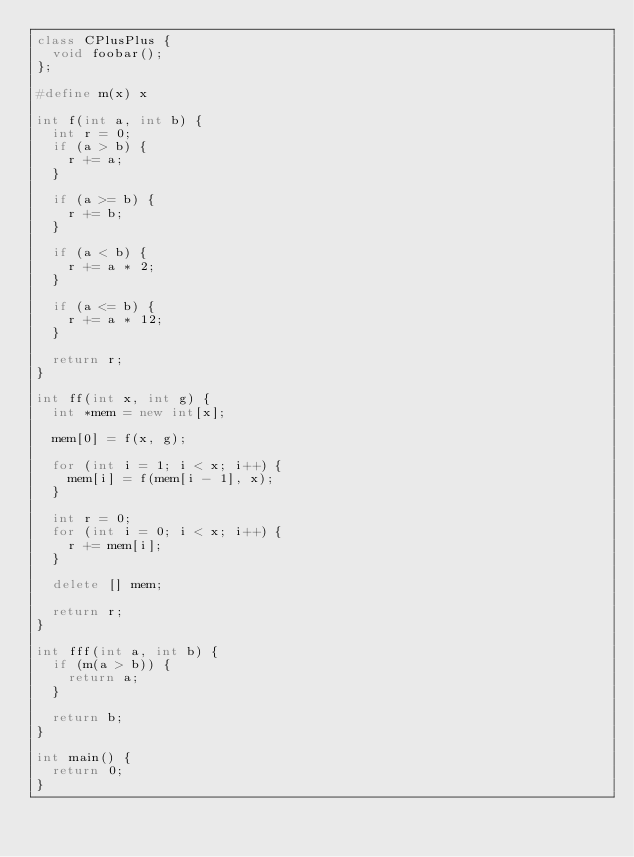Convert code to text. <code><loc_0><loc_0><loc_500><loc_500><_C++_>class CPlusPlus {
  void foobar();
};

#define m(x) x

int f(int a, int b) {
  int r = 0;
  if (a > b) {
    r += a;
  }

  if (a >= b) {
    r += b;
  }

  if (a < b) {
    r += a * 2;
  }

  if (a <= b) {
    r += a * 12;
  }

  return r;
}

int ff(int x, int g) {
  int *mem = new int[x];

  mem[0] = f(x, g);

  for (int i = 1; i < x; i++) {
    mem[i] = f(mem[i - 1], x);
  }

  int r = 0;
  for (int i = 0; i < x; i++) {
    r += mem[i];
  }

  delete [] mem;

  return r;
}

int fff(int a, int b) {
  if (m(a > b)) {
    return a;
  }

  return b;
}

int main() {
  return 0;
}

</code> 